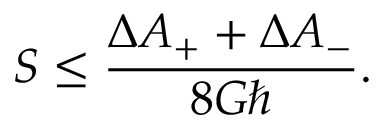<formula> <loc_0><loc_0><loc_500><loc_500>S \leq { \frac { \Delta A _ { + } + \Delta A _ { - } } { 8 G } } .</formula> 